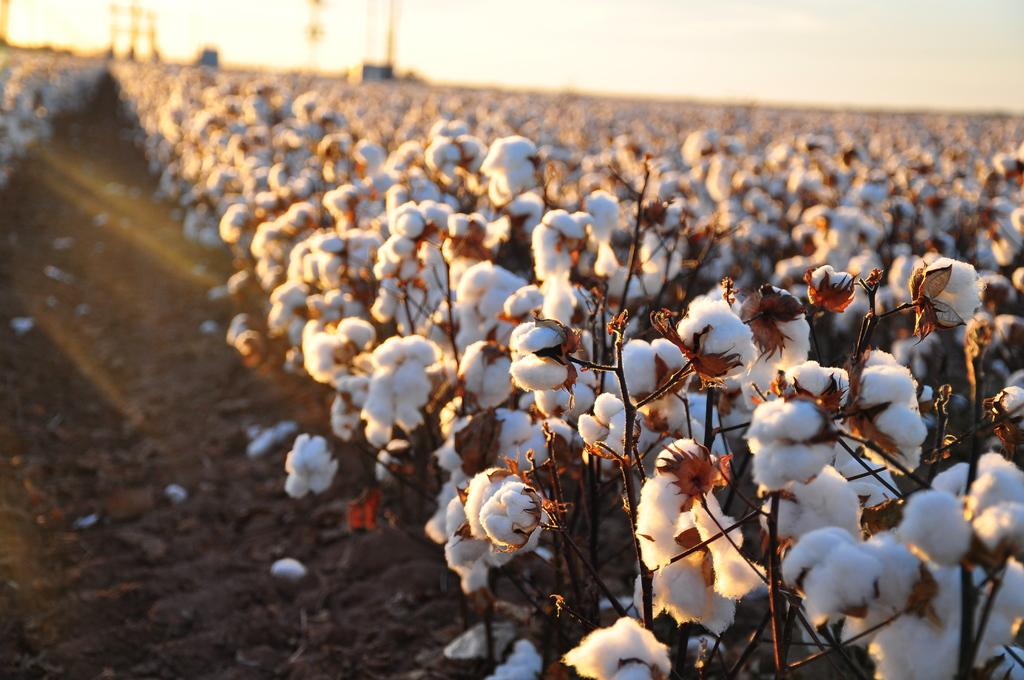What type of plants are in the image? There are cotton plants in the image. What is the state of the cotton plants? The cotton plants have cotton on them. What else can be seen in the image besides the cotton plants? There are poles visible in the image. What is visible at the top of the image? The sky is visible at the top of the image. What is present at the bottom of the image? Mud is present at the bottom of the image. Can you tell me how many tomatoes are growing on the cotton plants in the image? There are no tomatoes present in the image; it features cotton plants. What type of salt can be seen on the cotton plants in the image? There is no salt present on the cotton plants in the image. 